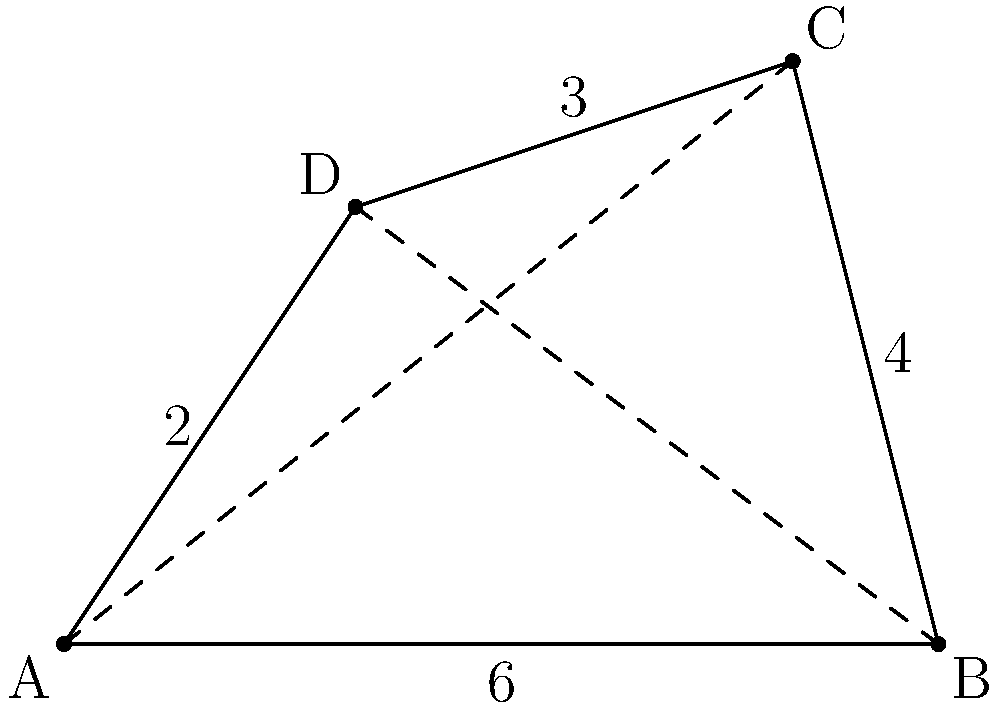An irregular quadrilateral ABCD has vertices at A(0,0), B(6,0), C(5,4), and D(2,3). Calculate the area of this quadrilateral using the vertices method. To find the area of an irregular quadrilateral given its vertices, we can use the following formula:

$$\text{Area} = \frac{1}{2}|(x_1y_2 + x_2y_3 + x_3y_4 + x_4y_1) - (y_1x_2 + y_2x_3 + y_3x_4 + y_4x_1)|$$

Where $(x_1, y_1)$, $(x_2, y_2)$, $(x_3, y_3)$, and $(x_4, y_4)$ are the coordinates of the four vertices in counterclockwise order.

Step 1: Identify the coordinates:
A: $(x_1, y_1) = (0, 0)$
B: $(x_2, y_2) = (6, 0)$
C: $(x_3, y_3) = (5, 4)$
D: $(x_4, y_4) = (2, 3)$

Step 2: Apply the formula:

$$\text{Area} = \frac{1}{2}|(0 \cdot 0 + 6 \cdot 4 + 5 \cdot 3 + 2 \cdot 0) - (0 \cdot 6 + 0 \cdot 5 + 4 \cdot 2 + 3 \cdot 0)|$$

Step 3: Simplify:

$$\text{Area} = \frac{1}{2}|(0 + 24 + 15 + 0) - (0 + 0 + 8 + 0)|$$
$$\text{Area} = \frac{1}{2}|39 - 8|$$
$$\text{Area} = \frac{1}{2}|31|$$
$$\text{Area} = \frac{31}{2}$$
$$\text{Area} = 15.5$$

Therefore, the area of the quadrilateral ABCD is 15.5 square units.
Answer: 15.5 square units 